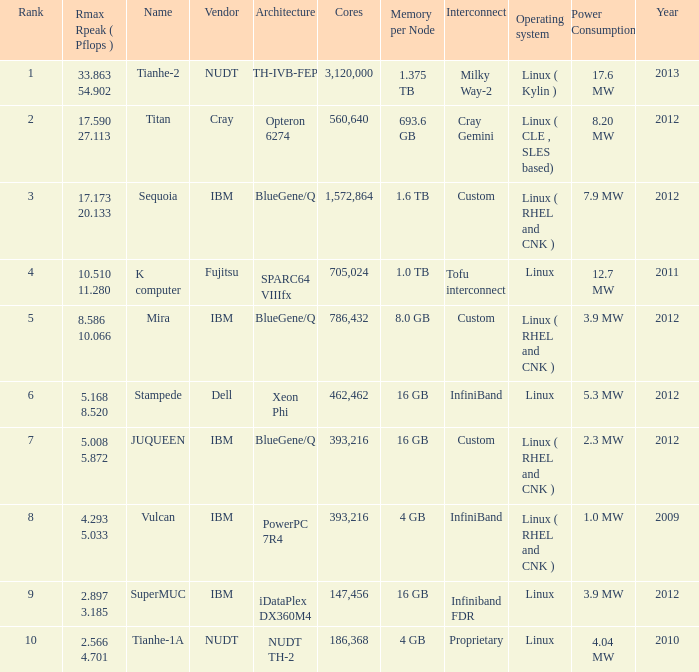What is the rank of Rmax Rpeak ( Pflops ) of 17.173 20.133? 3.0. 